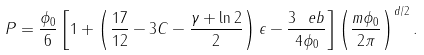<formula> <loc_0><loc_0><loc_500><loc_500>P = \frac { \phi _ { 0 } } 6 \left [ 1 + \left ( \frac { 1 7 } { 1 2 } - 3 C - \frac { \gamma + \ln 2 } 2 \right ) \epsilon - \frac { 3 \ e b } { 4 \phi _ { 0 } } \right ] \left ( \frac { m \phi _ { 0 } } { 2 \pi } \right ) ^ { d / 2 } .</formula> 